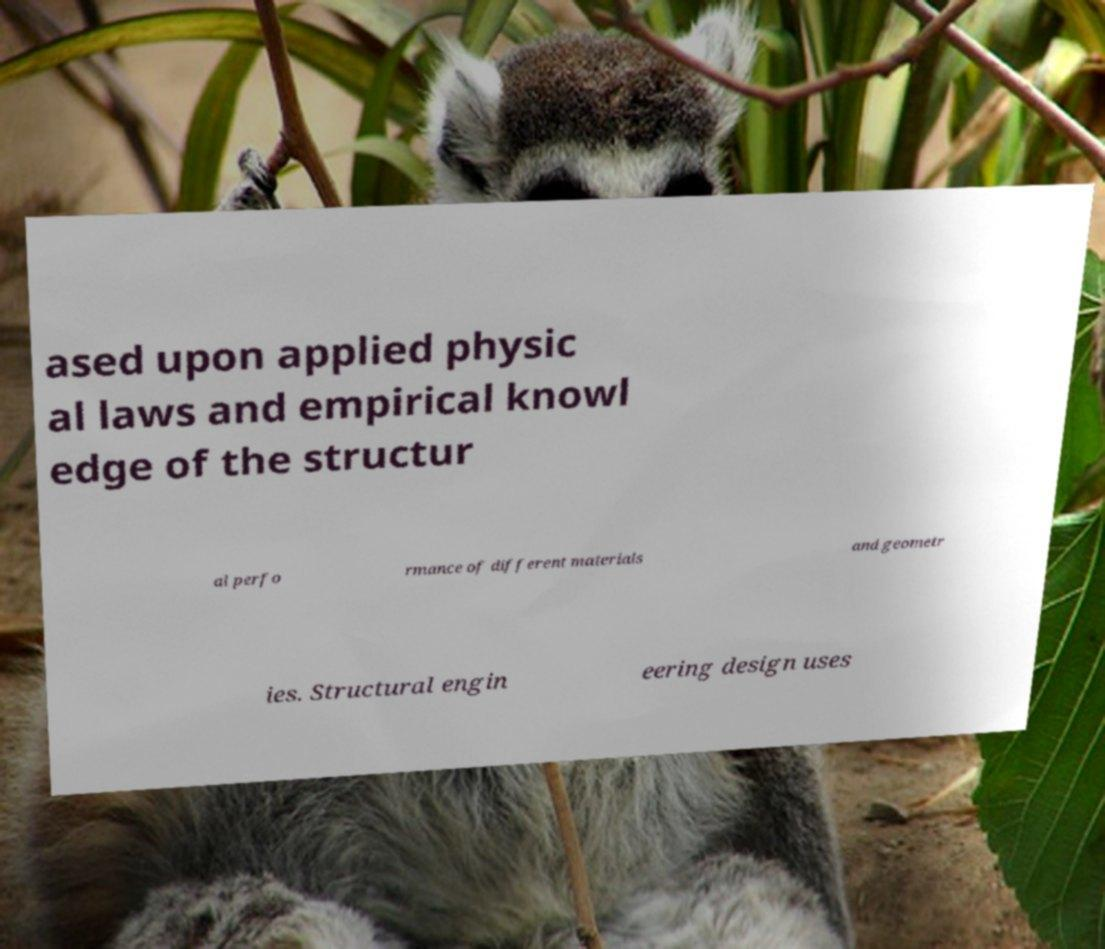I need the written content from this picture converted into text. Can you do that? ased upon applied physic al laws and empirical knowl edge of the structur al perfo rmance of different materials and geometr ies. Structural engin eering design uses 